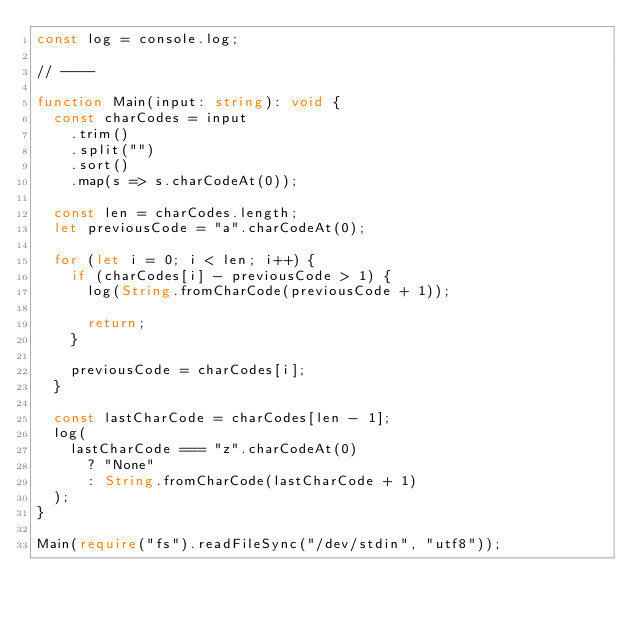Convert code to text. <code><loc_0><loc_0><loc_500><loc_500><_TypeScript_>const log = console.log;

// ----

function Main(input: string): void {
  const charCodes = input
    .trim()
    .split("")
    .sort()
    .map(s => s.charCodeAt(0));

  const len = charCodes.length;
  let previousCode = "a".charCodeAt(0);

  for (let i = 0; i < len; i++) {
    if (charCodes[i] - previousCode > 1) {
      log(String.fromCharCode(previousCode + 1));

      return;
    }

    previousCode = charCodes[i];
  }

  const lastCharCode = charCodes[len - 1];
  log(
    lastCharCode === "z".charCodeAt(0)
      ? "None"
      : String.fromCharCode(lastCharCode + 1)
  );
}

Main(require("fs").readFileSync("/dev/stdin", "utf8"));</code> 